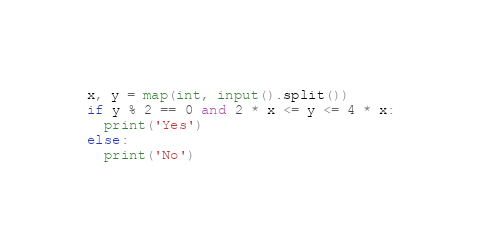Convert code to text. <code><loc_0><loc_0><loc_500><loc_500><_Python_>x, y = map(int, input().split())
if y % 2 == 0 and 2 * x <= y <= 4 * x:
  print('Yes')
else:
  print('No')
</code> 